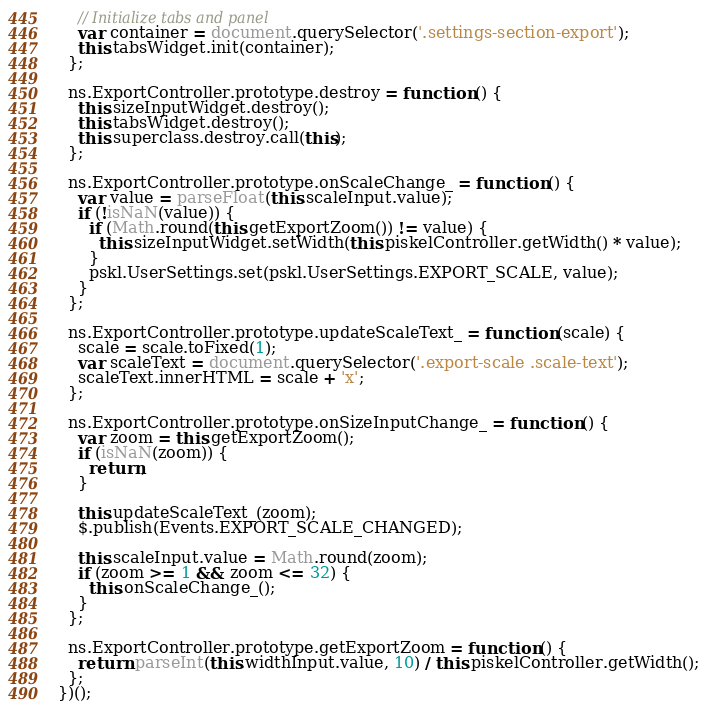Convert code to text. <code><loc_0><loc_0><loc_500><loc_500><_JavaScript_>    // Initialize tabs and panel
    var container = document.querySelector('.settings-section-export');
    this.tabsWidget.init(container);
  };

  ns.ExportController.prototype.destroy = function () {
    this.sizeInputWidget.destroy();
    this.tabsWidget.destroy();
    this.superclass.destroy.call(this);
  };

  ns.ExportController.prototype.onScaleChange_ = function () {
    var value = parseFloat(this.scaleInput.value);
    if (!isNaN(value)) {
      if (Math.round(this.getExportZoom()) != value) {
        this.sizeInputWidget.setWidth(this.piskelController.getWidth() * value);
      }
      pskl.UserSettings.set(pskl.UserSettings.EXPORT_SCALE, value);
    }
  };

  ns.ExportController.prototype.updateScaleText_ = function (scale) {
    scale = scale.toFixed(1);
    var scaleText = document.querySelector('.export-scale .scale-text');
    scaleText.innerHTML = scale + 'x';
  };

  ns.ExportController.prototype.onSizeInputChange_ = function () {
    var zoom = this.getExportZoom();
    if (isNaN(zoom)) {
      return;
    }

    this.updateScaleText_(zoom);
    $.publish(Events.EXPORT_SCALE_CHANGED);

    this.scaleInput.value = Math.round(zoom);
    if (zoom >= 1 && zoom <= 32) {
      this.onScaleChange_();
    }
  };

  ns.ExportController.prototype.getExportZoom = function () {
    return parseInt(this.widthInput.value, 10) / this.piskelController.getWidth();
  };
})();
</code> 